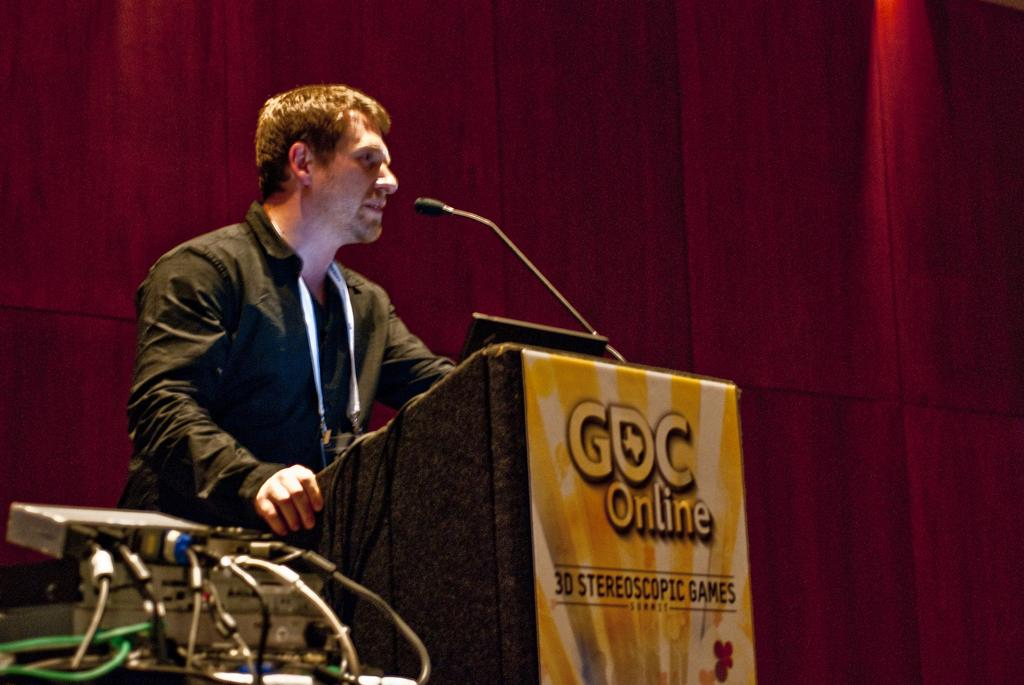<image>
Summarize the visual content of the image. A man stands at a podium that says GOC Online on it. 